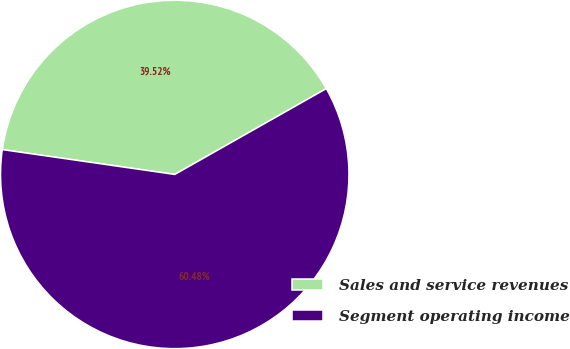<chart> <loc_0><loc_0><loc_500><loc_500><pie_chart><fcel>Sales and service revenues<fcel>Segment operating income<nl><fcel>39.52%<fcel>60.48%<nl></chart> 